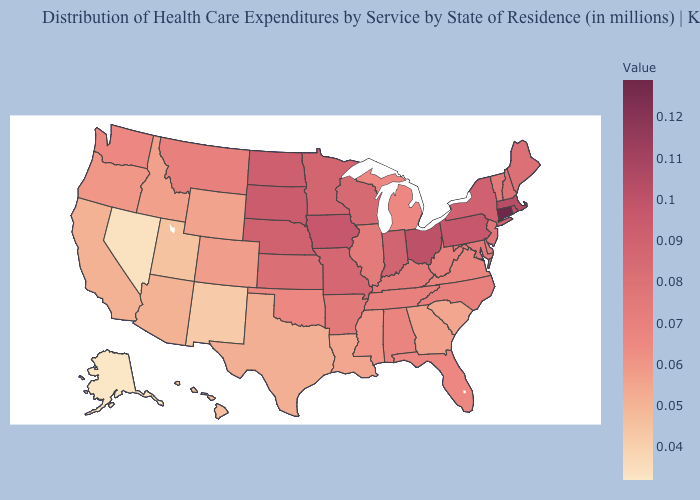Is the legend a continuous bar?
Concise answer only. Yes. Does Alaska have the lowest value in the USA?
Quick response, please. Yes. Does the map have missing data?
Write a very short answer. No. Among the states that border Wisconsin , which have the lowest value?
Quick response, please. Michigan. Does Florida have a lower value than Missouri?
Write a very short answer. Yes. Does Connecticut have the highest value in the USA?
Give a very brief answer. Yes. Is the legend a continuous bar?
Keep it brief. Yes. Does Washington have a higher value than Iowa?
Short answer required. No. 